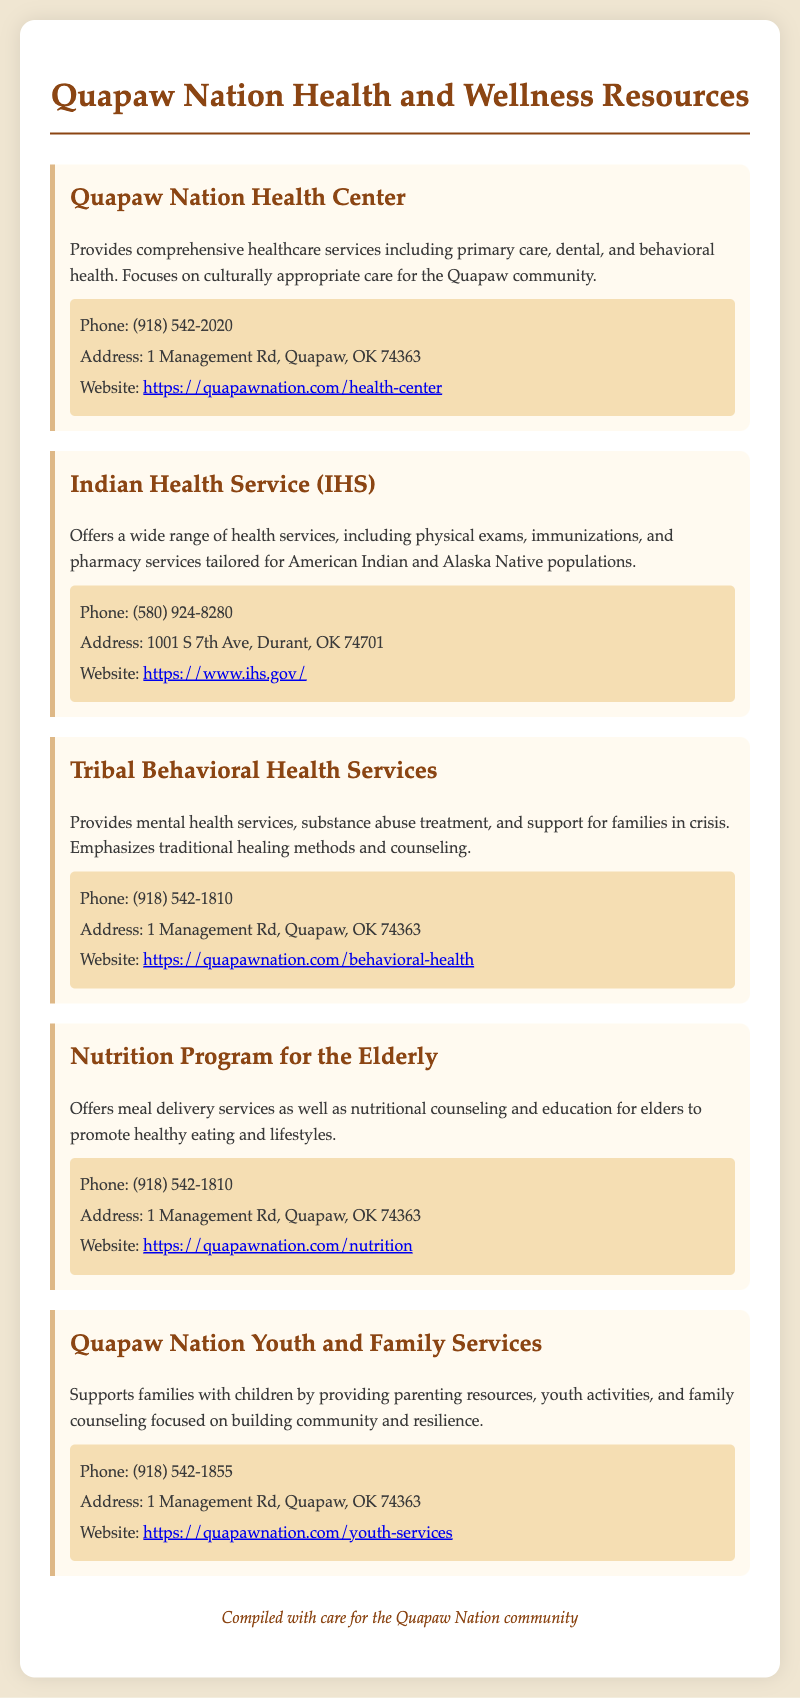What services does the Quapaw Nation Health Center provide? The Quapaw Nation Health Center provides comprehensive healthcare services including primary care, dental, and behavioral health.
Answer: Comprehensive healthcare services including primary care, dental, and behavioral health What is the phone number for the Indian Health Service? The phone number for the Indian Health Service is provided in the contact information section.
Answer: (580) 924-8280 Where is the Tribal Behavioral Health Services located? The address for the Tribal Behavioral Health Services is listed along with its contact information.
Answer: 1 Management Rd, Quapaw, OK 74363 What program focuses on meal delivery for elders? The document describes a program dedicated to elderly community members, which includes meal delivery services.
Answer: Nutrition Program for the Elderly How can families get support for children? The Quapaw Nation Youth and Family Services supports families with children.
Answer: Quapaw Nation Youth and Family Services What type of health services does the Indian Health Service offer? The Indian Health Service provides a wide range of health services tailored for specific populations.
Answer: Health services including physical exams, immunizations, and pharmacy services What website can be visited for information on the Quapaw Nation Health Center? The website link is mentioned in the contact information of the Quapaw Nation Health Center.
Answer: https://quapawnation.com/health-center What emphasis does Tribal Behavioral Health Services place on its treatment? The treatment approach of the Tribal Behavioral Health Services is highlighted in its description.
Answer: Emphasizes traditional healing methods and counseling 